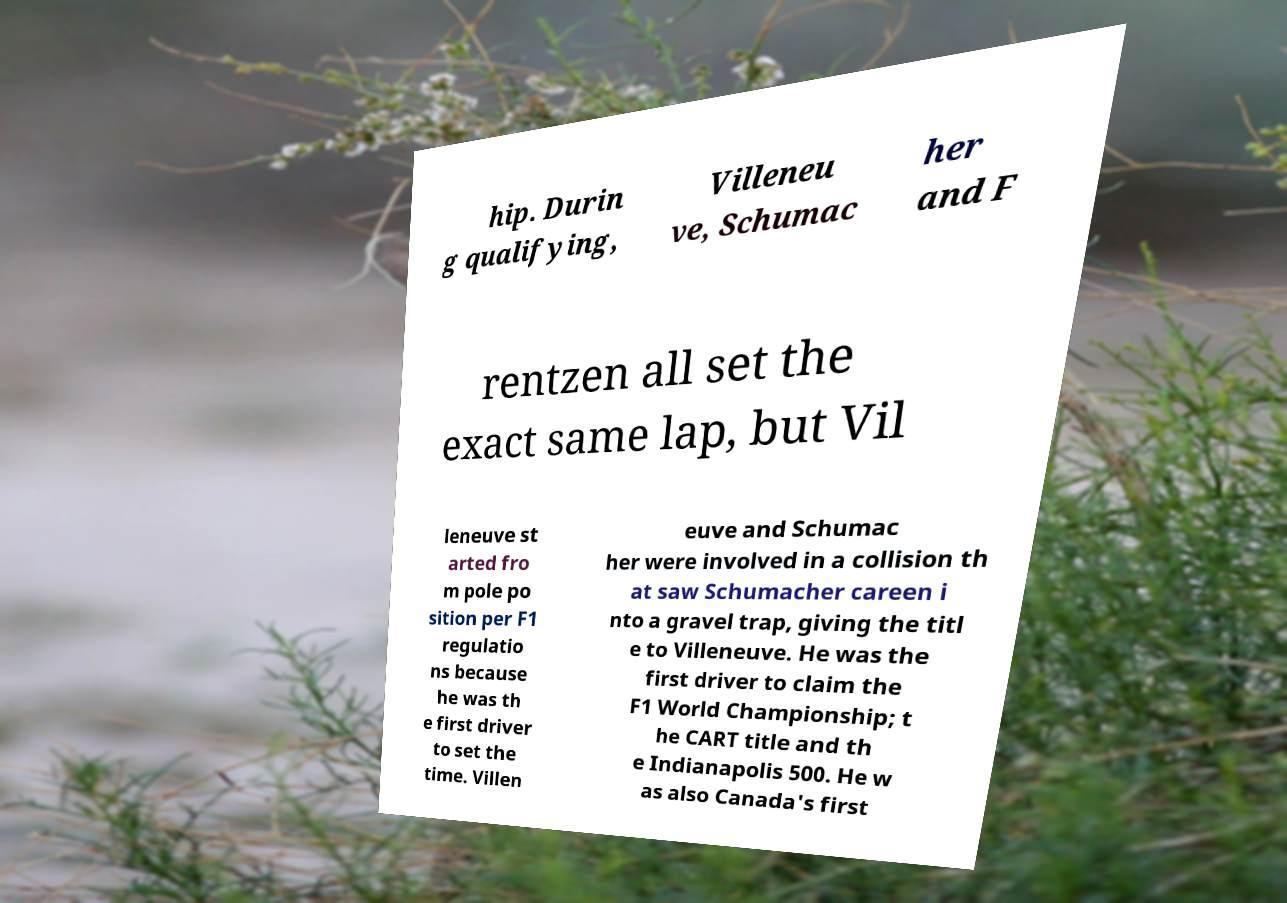I need the written content from this picture converted into text. Can you do that? hip. Durin g qualifying, Villeneu ve, Schumac her and F rentzen all set the exact same lap, but Vil leneuve st arted fro m pole po sition per F1 regulatio ns because he was th e first driver to set the time. Villen euve and Schumac her were involved in a collision th at saw Schumacher careen i nto a gravel trap, giving the titl e to Villeneuve. He was the first driver to claim the F1 World Championship; t he CART title and th e Indianapolis 500. He w as also Canada's first 